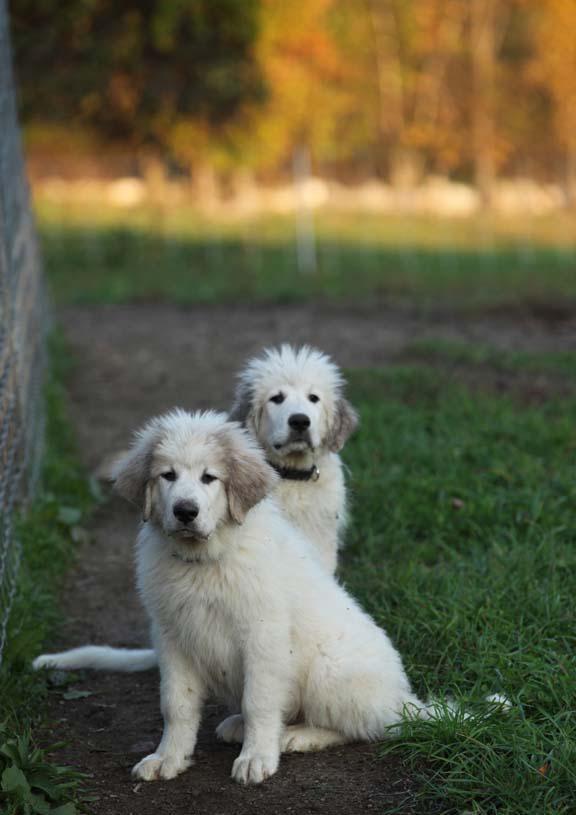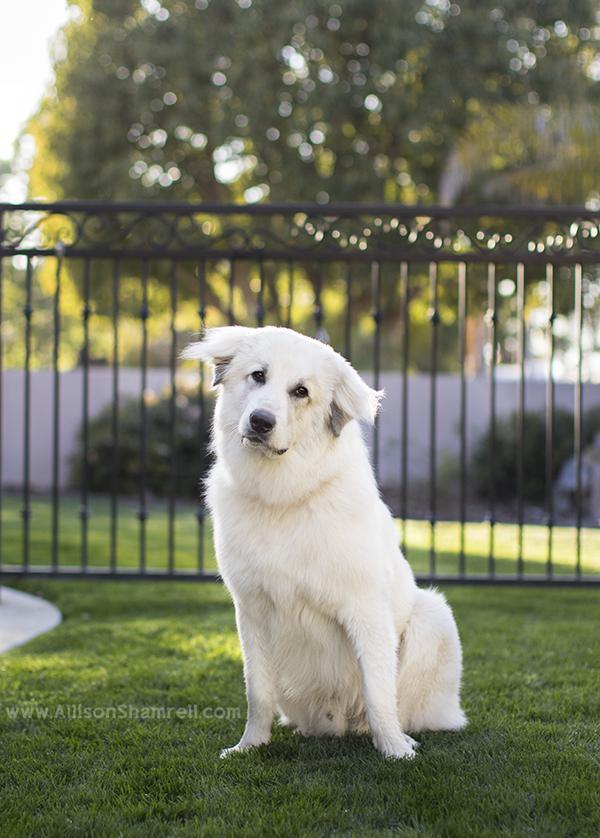The first image is the image on the left, the second image is the image on the right. For the images displayed, is the sentence "a dog is laying in the grass in the left image" factually correct? Answer yes or no. No. The first image is the image on the left, the second image is the image on the right. Assess this claim about the two images: "A young puppy is lying down in one of the images.". Correct or not? Answer yes or no. No. 